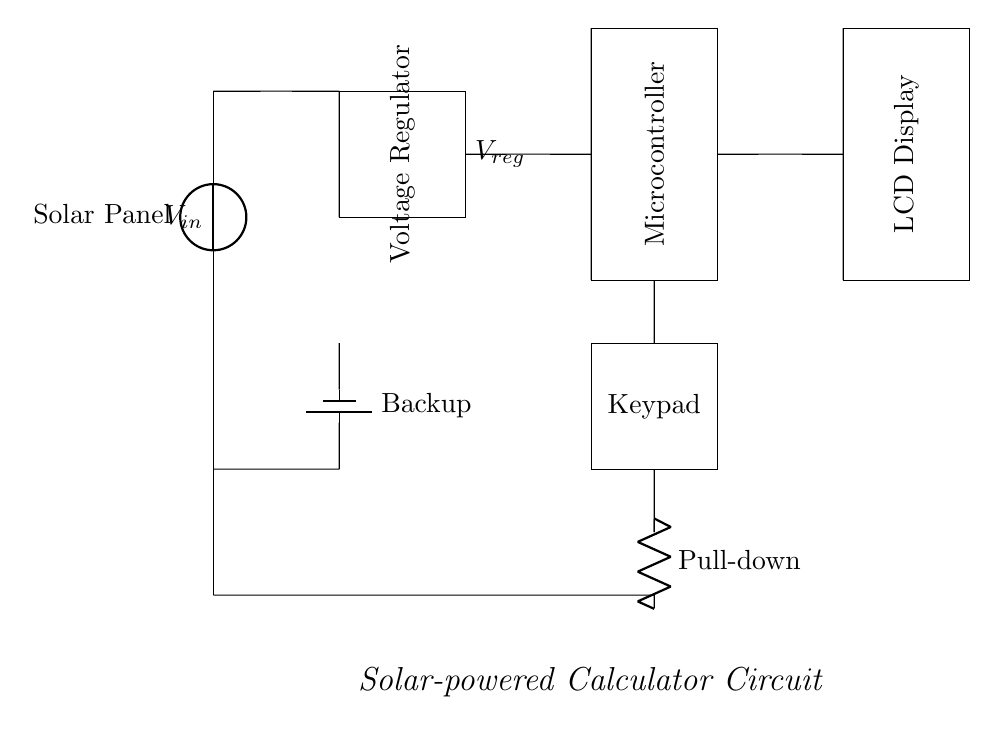What is the main power source for this calculator? The main power source is the solar panel located at the top of the circuit diagram, which collects solar energy to provide electricity.
Answer: Solar panel What component regulates the voltage in this circuit? The voltage regulator, depicted as a rectangle labeled accordingly, is responsible for ensuring that the output voltage remains stable despite variations in the solar panel's output.
Answer: Voltage regulator How many main components are there in this circuit? By counting the distinct functional blocks in the circuit — solar panel, voltage regulator, microcontroller, LCD display, keypad, and backup battery — we find there are six main components.
Answer: Six What is the function of the backup battery? The backup battery provides supplemental power to the circuit when the solar panel cannot, ensuring consistent operation in low-light conditions or during nighttime.
Answer: Backup What is connected to the keypad? The keypad connects to the microcontroller, sending user input signals to process calculations as indicated by the wiring between these two components.
Answer: Microcontroller What role does the LCD display serve in this circuit? The LCD display visually presents the output of calculations and results performed by the microcontroller, allowing users to interact with the calculator.
Answer: Display output What does the pull-down resistor do in this circuit? The pull-down resistor ensures that the keypad signals are grounded when not pressed, preventing floating inputs that could cause erratic behavior in the microcontroller.
Answer: Stabilizes input 